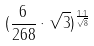Convert formula to latex. <formula><loc_0><loc_0><loc_500><loc_500>( \frac { 6 } { 2 6 8 } \cdot \sqrt { 3 } ) ^ { \frac { 1 \cdot 1 } { \sqrt { 8 } } }</formula> 